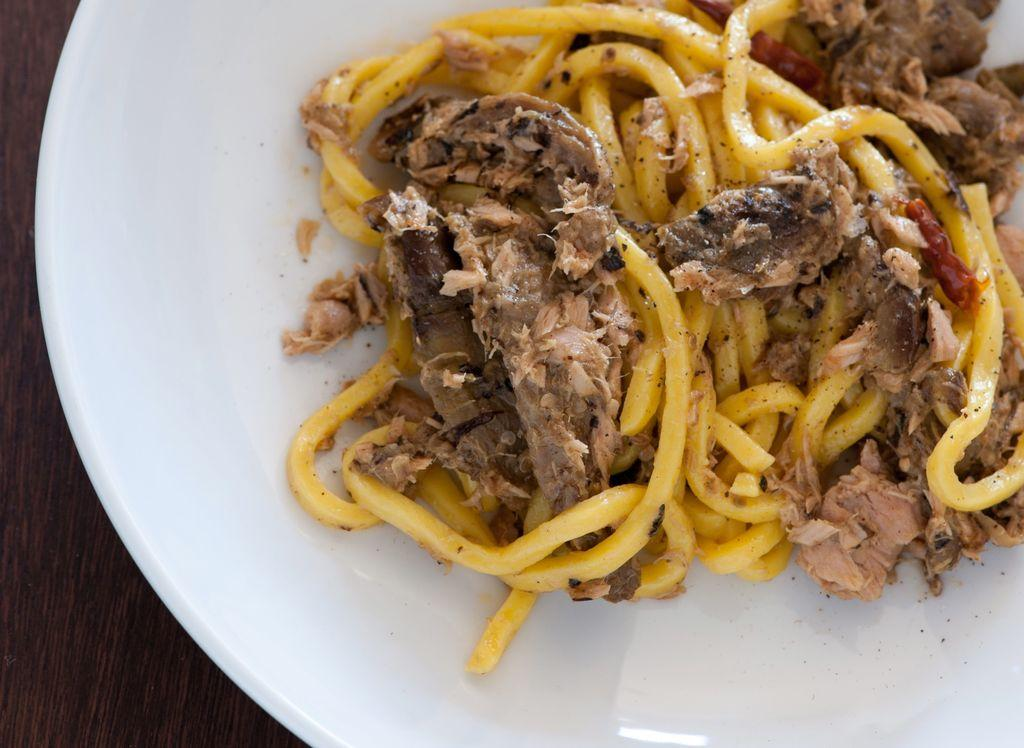What is on the plate that is visible in the image? There is food on a plate in the image. What color is the plate? The plate is white. On what type of surface is the plate placed? The plate is kept on a wooden surface. What type of needle is used to sew the frame in the image? There is no needle or frame present in the image; it only features a plate of food on a wooden surface. 